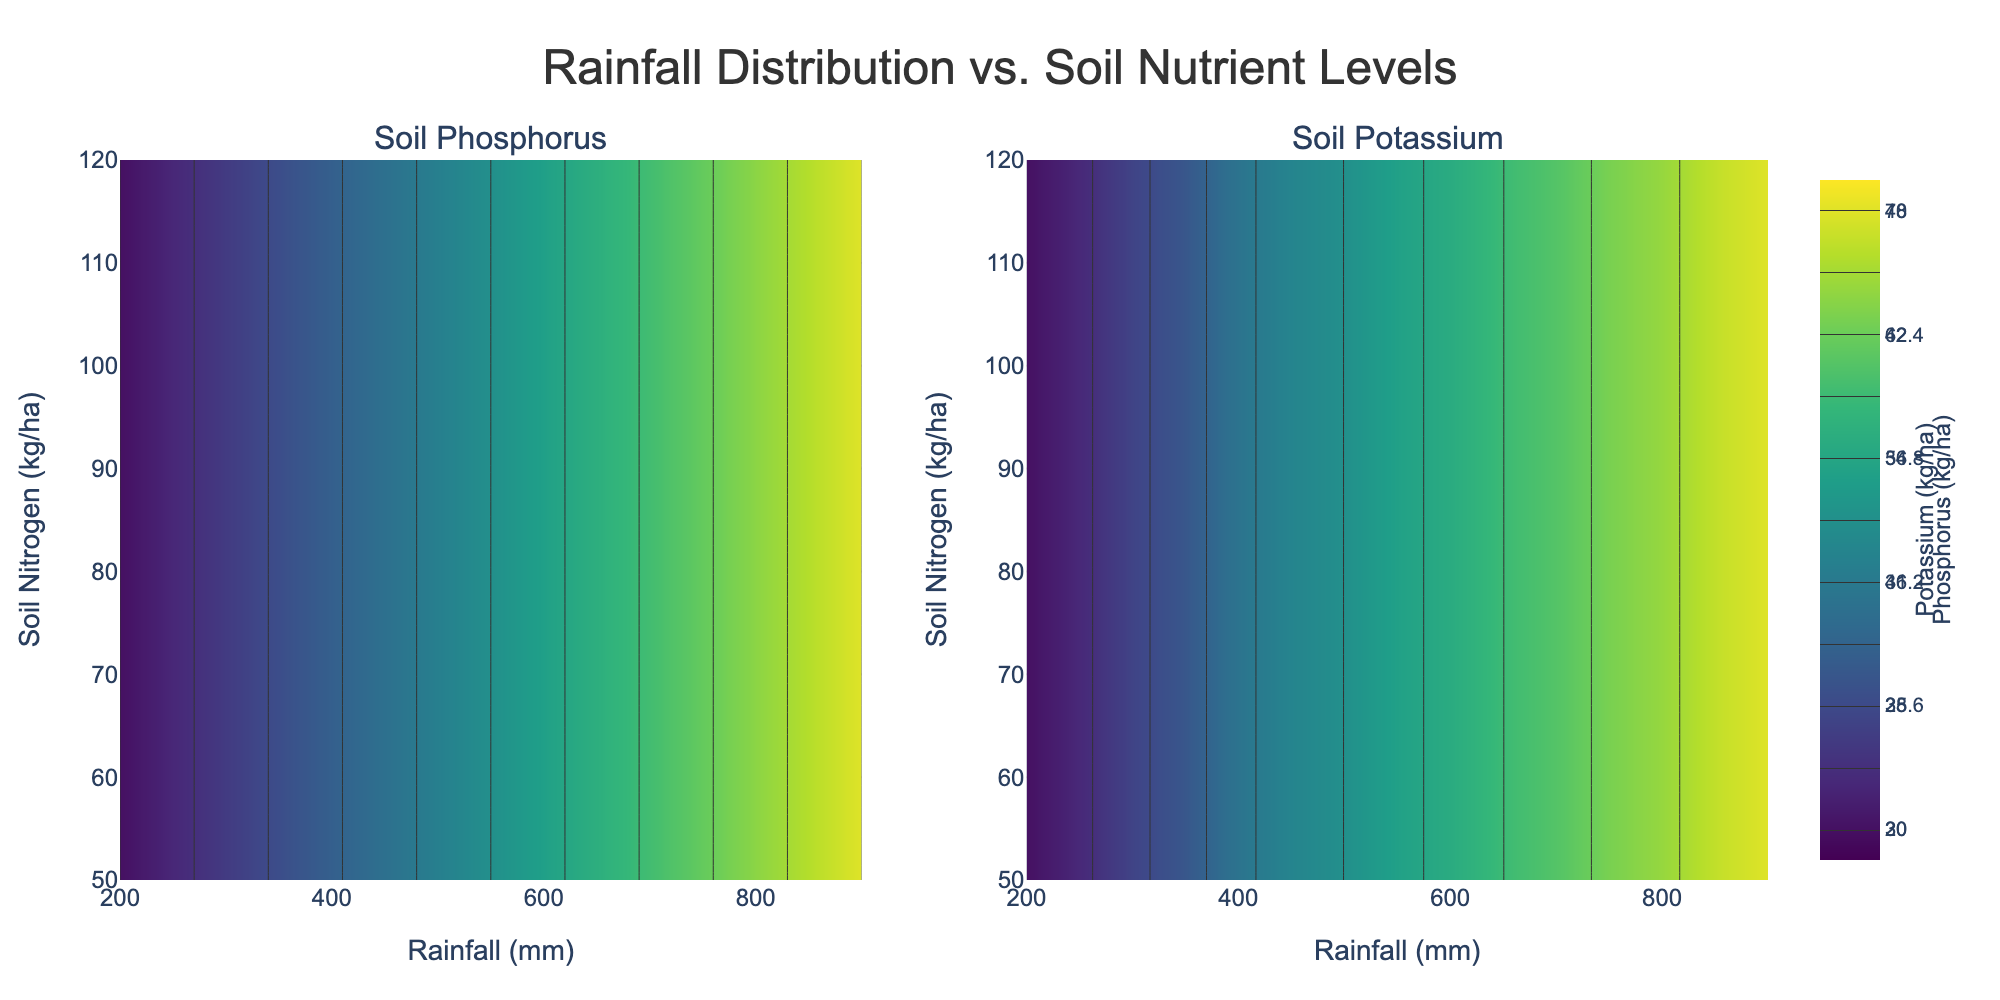How many subplots are there in the figure? There are two separate contour plots side-by-side, as indicated by the columns in the subplot_titles.
Answer: 2 What are the titles of the subplots? The titles are visible atop each subplot. The left subplot is titled 'Soil Phosphorus', and the right one is titled 'Soil Potassium'.
Answer: Soil Phosphorus, Soil Potassium What does the color represent in the contour plots? The color in each contour plot represents different levels of soil nutrients: Phosphorus on the left and Potassium on the right, as indicated by the colorbars.
Answer: Soil nutrient levels Which subplot shows the relationship between Rainfall and Soil Potassium? The subplot on the right shows this relationship, as identified by its title 'Soil Potassium'.
Answer: Right subplot What is the range of Rainfall (mm) shown on the x-axis? The x-axis shows Rainfall values ranging from 200 mm to 900 mm, as indicated by the axis labels.
Answer: 200-900 mm At what Rainfall value is the Soil Nitrogen the highest? By observing the y-axis where 'Soil Nitrogen' is labeled, the maximum Soil Nitrogen (kg/ha) is indicated to be at the highest tick value which aligns vertically with the maximum Rainfall (900 mm).
Answer: 900 mm What soil nutrient is depicted in the first subplot? The first subplot is labeled with the title 'Soil Phosphorus', indicating it depicts Soil Phosphorus levels.
Answer: Soil Phosphorus Which subplot tends to have higher nutrient levels depicted with more intense colors? The intensity of colors in the contour plots indicates higher nutrient levels; observe which subplot has more of the darkest shades.
Answer: Right subplot What is the minimum value of Soil Potassium visible in the contour plot? The colorbar on the right subplot indicates the minimum value of Soil Potassium, which is labeled as 30 kg/ha.
Answer: 30 kg/ha What is the maximum value of Soil Phosphorus evident in the figure? The colorbar on the left subplot shows the maximum value of Soil Phosphorus, which is labeled 48 kg/ha.
Answer: 48 kg/ha 